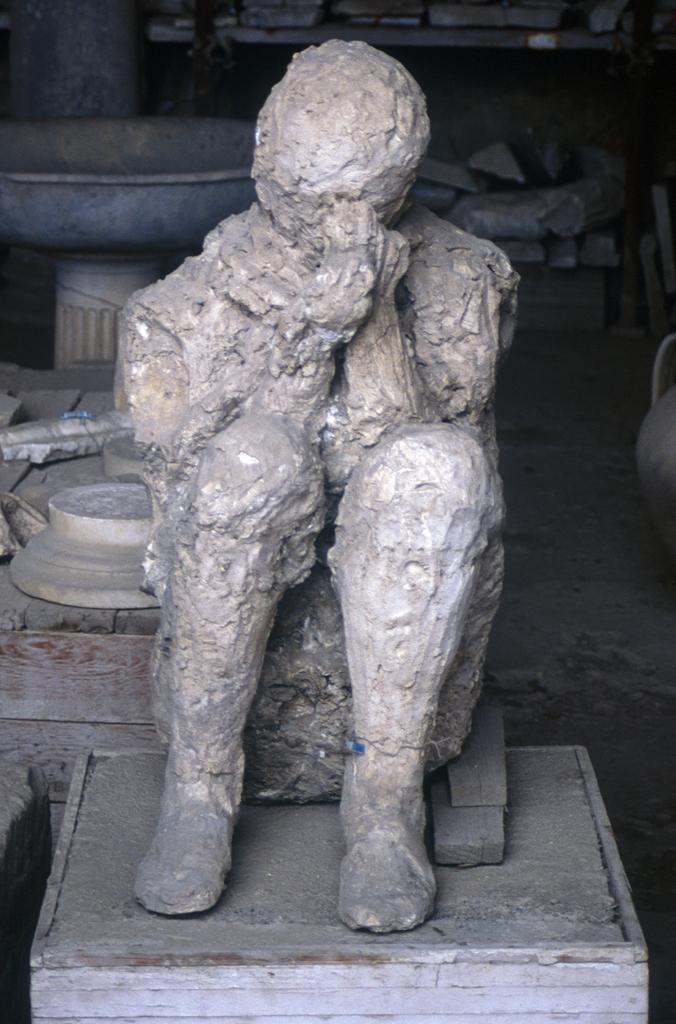What is the main subject of the image? There is a sculpture of a person in the image. Where is the sculpture located? The sculpture is placed on a table. What else can be seen in the image besides the sculpture? There are other objects visible in the background of the image. Can you describe the setting of the image? The image is an inside view. How many spoons are being used to stir the cream in the image? There is no cream or spoon present in the image. 